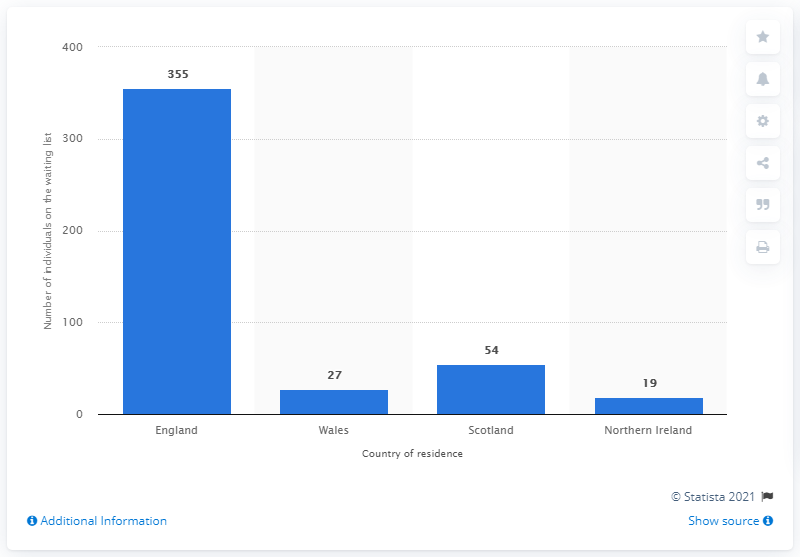Outline some significant characteristics in this image. In March 2020, there were 355 individuals on the liver transplant waiting list in England. 